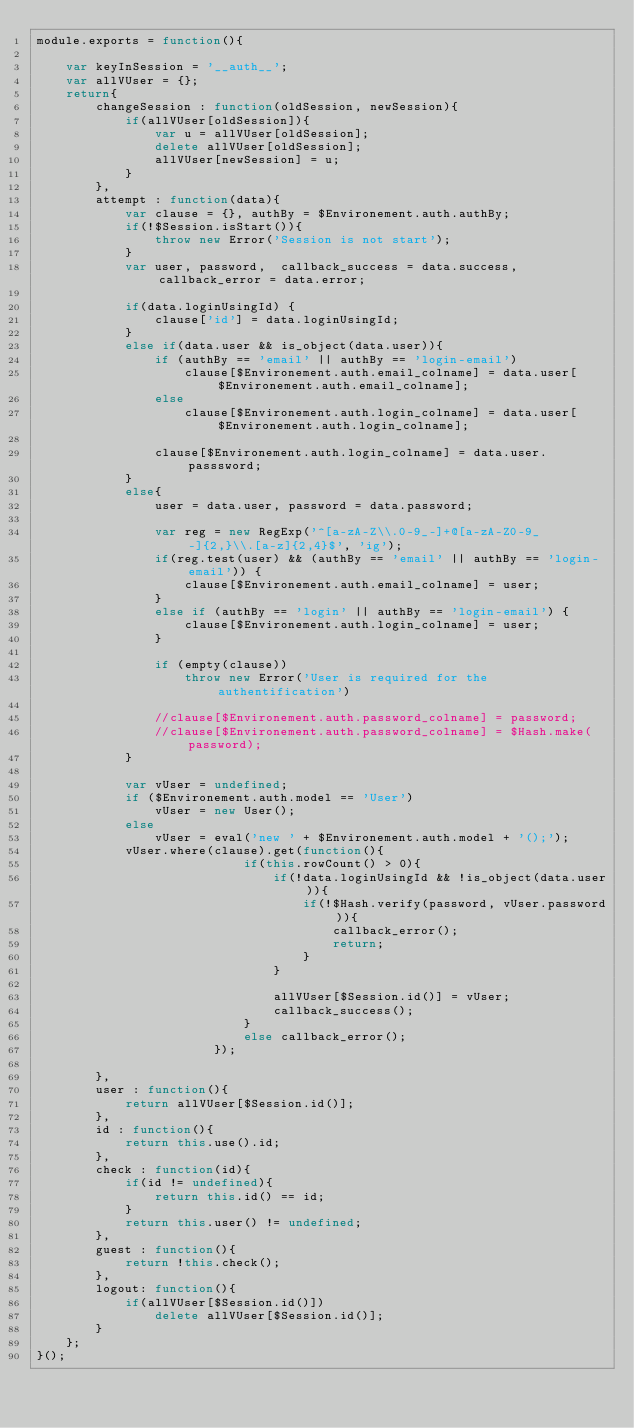<code> <loc_0><loc_0><loc_500><loc_500><_JavaScript_>module.exports = function(){

    var keyInSession = '__auth__';
    var allVUser = {};
    return{
        changeSession : function(oldSession, newSession){
            if(allVUser[oldSession]){
                var u = allVUser[oldSession];
                delete allVUser[oldSession];
                allVUser[newSession] = u;
            }
        },
        attempt : function(data){
            var clause = {}, authBy = $Environement.auth.authBy;
            if(!$Session.isStart()){
                throw new Error('Session is not start');
            }
            var user, password,  callback_success = data.success,  callback_error = data.error;

            if(data.loginUsingId) {
                clause['id'] = data.loginUsingId;
            }
            else if(data.user && is_object(data.user)){
                if (authBy == 'email' || authBy == 'login-email')
                    clause[$Environement.auth.email_colname] = data.user[$Environement.auth.email_colname];
                else
                    clause[$Environement.auth.login_colname] = data.user[$Environement.auth.login_colname];

                clause[$Environement.auth.login_colname] = data.user.passsword;
            }
            else{
                user = data.user, password = data.password;

                var reg = new RegExp('^[a-zA-Z\\.0-9_-]+@[a-zA-Z0-9_-]{2,}\\.[a-z]{2,4}$', 'ig');
                if(reg.test(user) && (authBy == 'email' || authBy == 'login-email')) {
                    clause[$Environement.auth.email_colname] = user;
                }
                else if (authBy == 'login' || authBy == 'login-email') {
                    clause[$Environement.auth.login_colname] = user;
                }

                if (empty(clause))
                    throw new Error('User is required for the authentification')

                //clause[$Environement.auth.password_colname] = password;
                //clause[$Environement.auth.password_colname] = $Hash.make(password);
            }

            var vUser = undefined;
            if ($Environement.auth.model == 'User')
                vUser = new User();
            else
                vUser = eval('new ' + $Environement.auth.model + '();');
            vUser.where(clause).get(function(){
                            if(this.rowCount() > 0){
                                if(!data.loginUsingId && !is_object(data.user)){
                                    if(!$Hash.verify(password, vUser.password)){
                                        callback_error();
                                        return;
                                    }
                                }

                                allVUser[$Session.id()] = vUser;
                                callback_success();
                            }
                            else callback_error();
                        });

        },
        user : function(){
            return allVUser[$Session.id()];
        },
        id : function(){
            return this.use().id;
        },
        check : function(id){
            if(id != undefined){
                return this.id() == id;
            }
            return this.user() != undefined;
        },
        guest : function(){
            return !this.check();
        },
        logout: function(){
            if(allVUser[$Session.id()])
                delete allVUser[$Session.id()];
        }
    };
}();</code> 